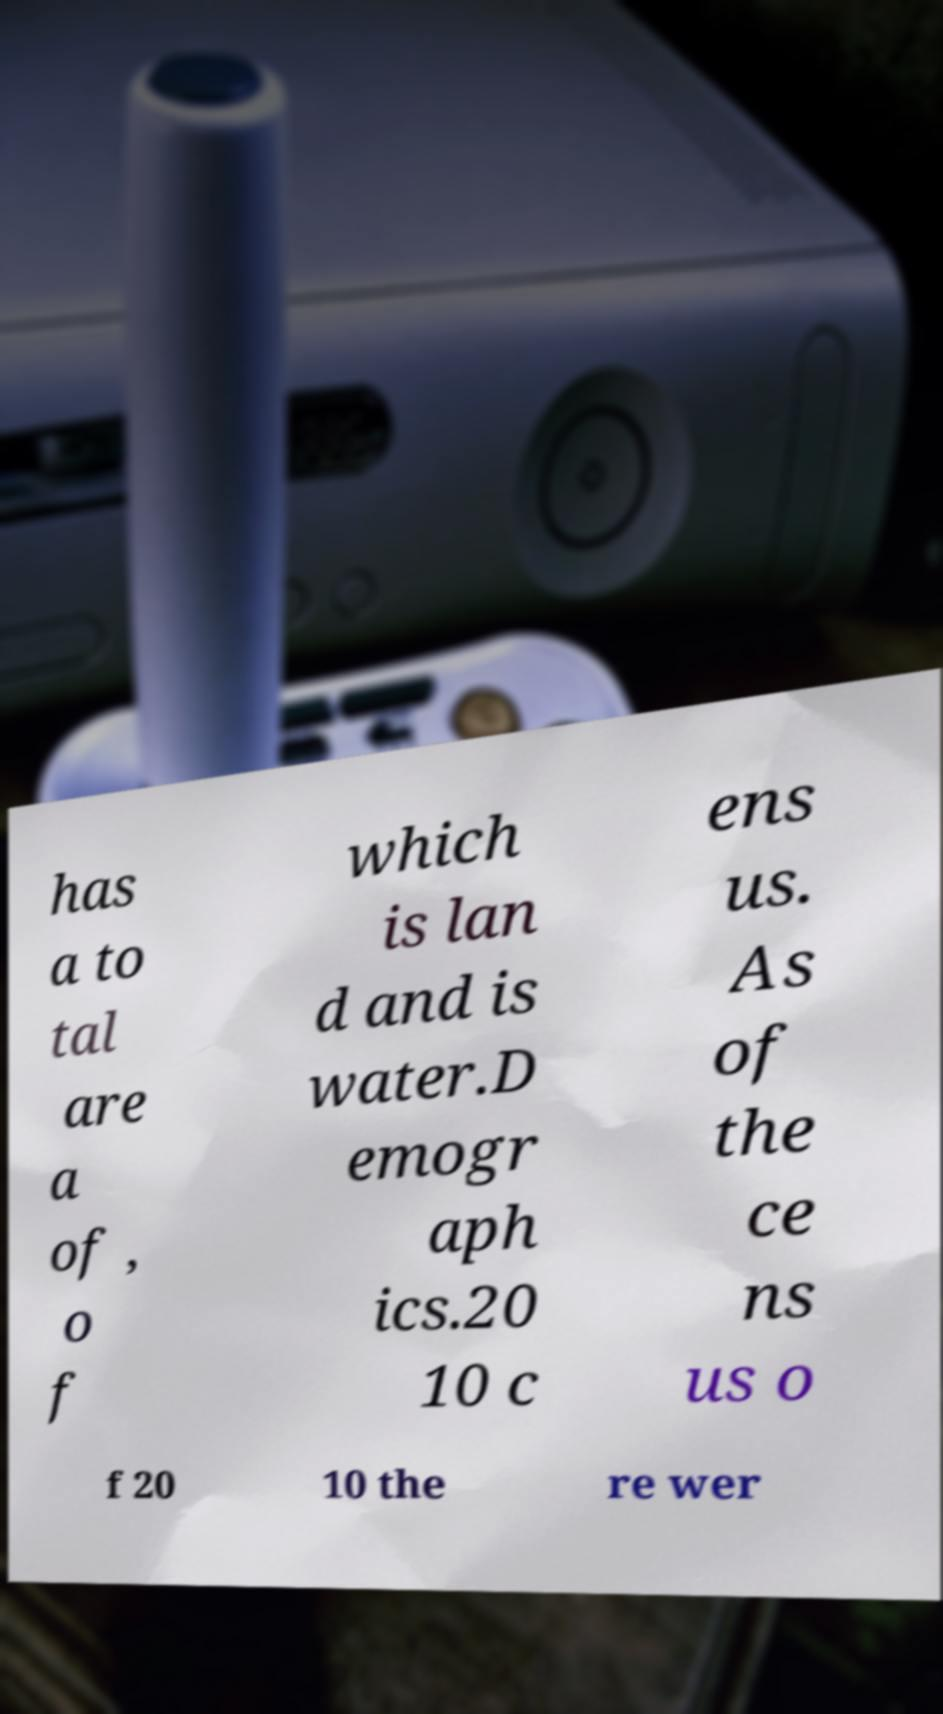Can you accurately transcribe the text from the provided image for me? has a to tal are a of , o f which is lan d and is water.D emogr aph ics.20 10 c ens us. As of the ce ns us o f 20 10 the re wer 